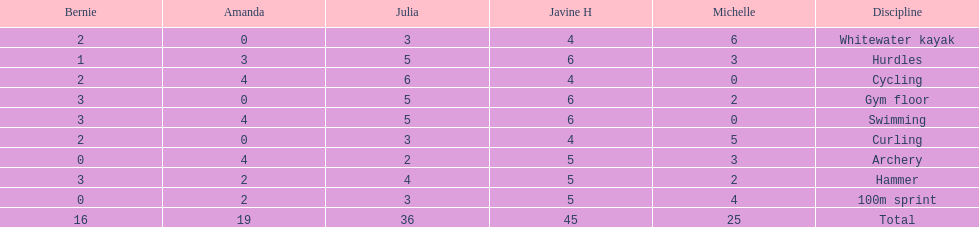Which of the girls had the least amount in archery? Bernie. 